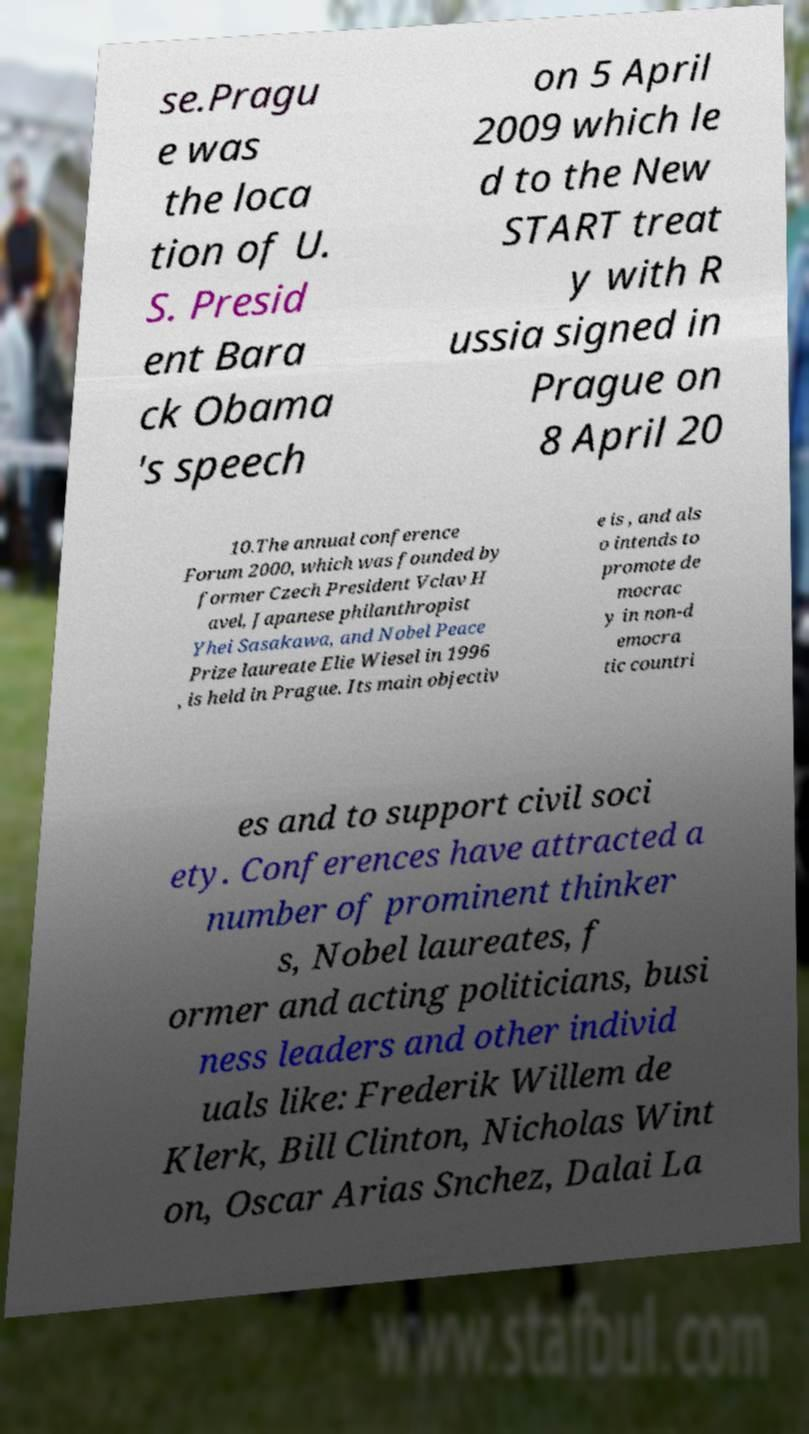Please identify and transcribe the text found in this image. se.Pragu e was the loca tion of U. S. Presid ent Bara ck Obama 's speech on 5 April 2009 which le d to the New START treat y with R ussia signed in Prague on 8 April 20 10.The annual conference Forum 2000, which was founded by former Czech President Vclav H avel, Japanese philanthropist Yhei Sasakawa, and Nobel Peace Prize laureate Elie Wiesel in 1996 , is held in Prague. Its main objectiv e is , and als o intends to promote de mocrac y in non-d emocra tic countri es and to support civil soci ety. Conferences have attracted a number of prominent thinker s, Nobel laureates, f ormer and acting politicians, busi ness leaders and other individ uals like: Frederik Willem de Klerk, Bill Clinton, Nicholas Wint on, Oscar Arias Snchez, Dalai La 